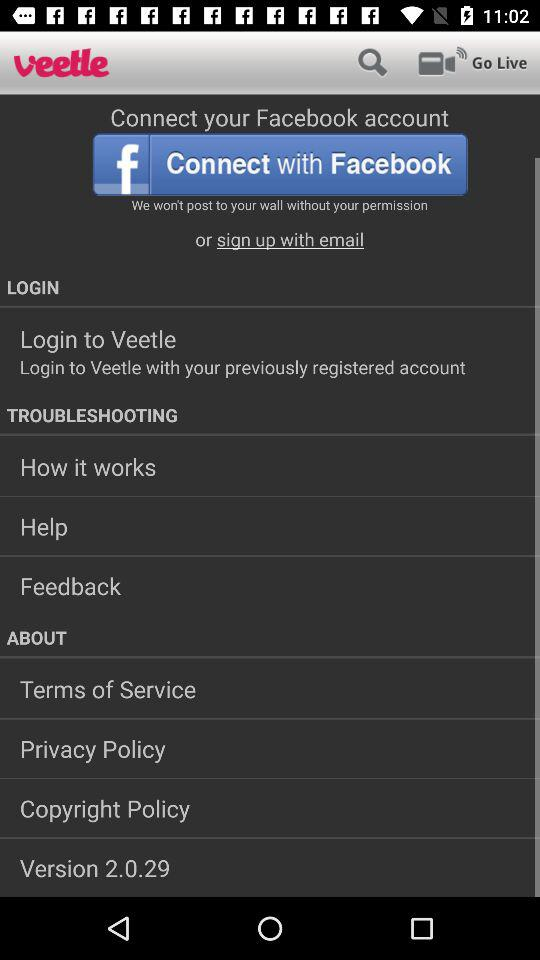What is the version? The version is 2.0.29. 